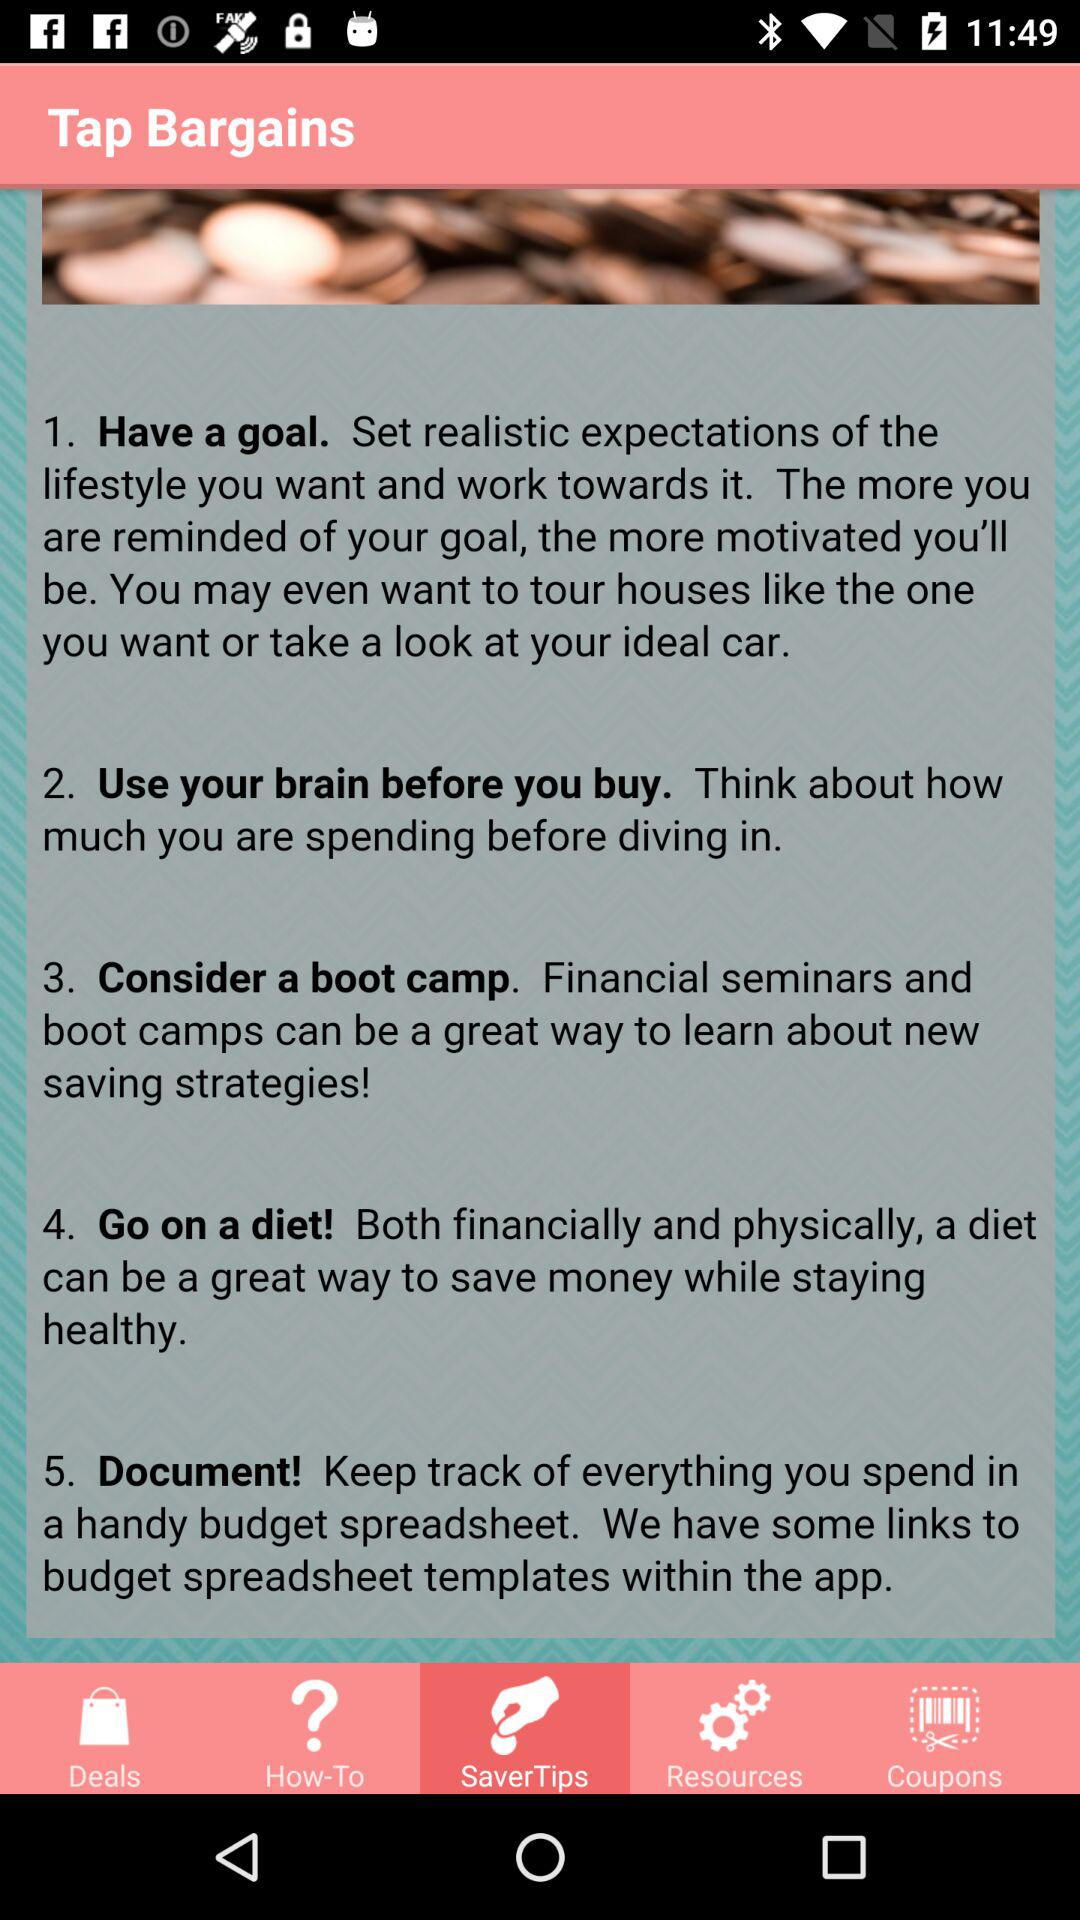How many tips are there about saving money?
Answer the question using a single word or phrase. 5 